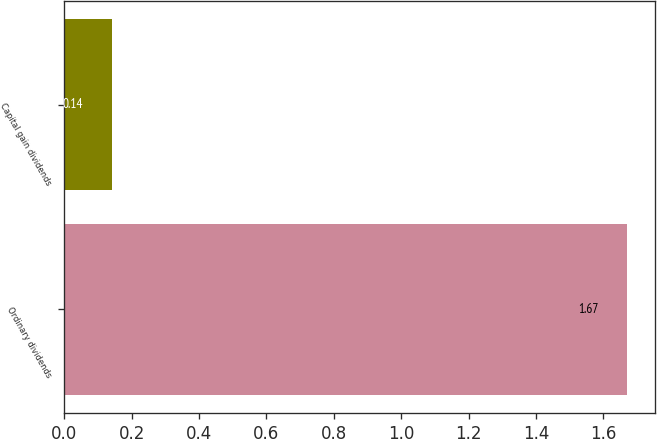Convert chart to OTSL. <chart><loc_0><loc_0><loc_500><loc_500><bar_chart><fcel>Ordinary dividends<fcel>Capital gain dividends<nl><fcel>1.67<fcel>0.14<nl></chart> 